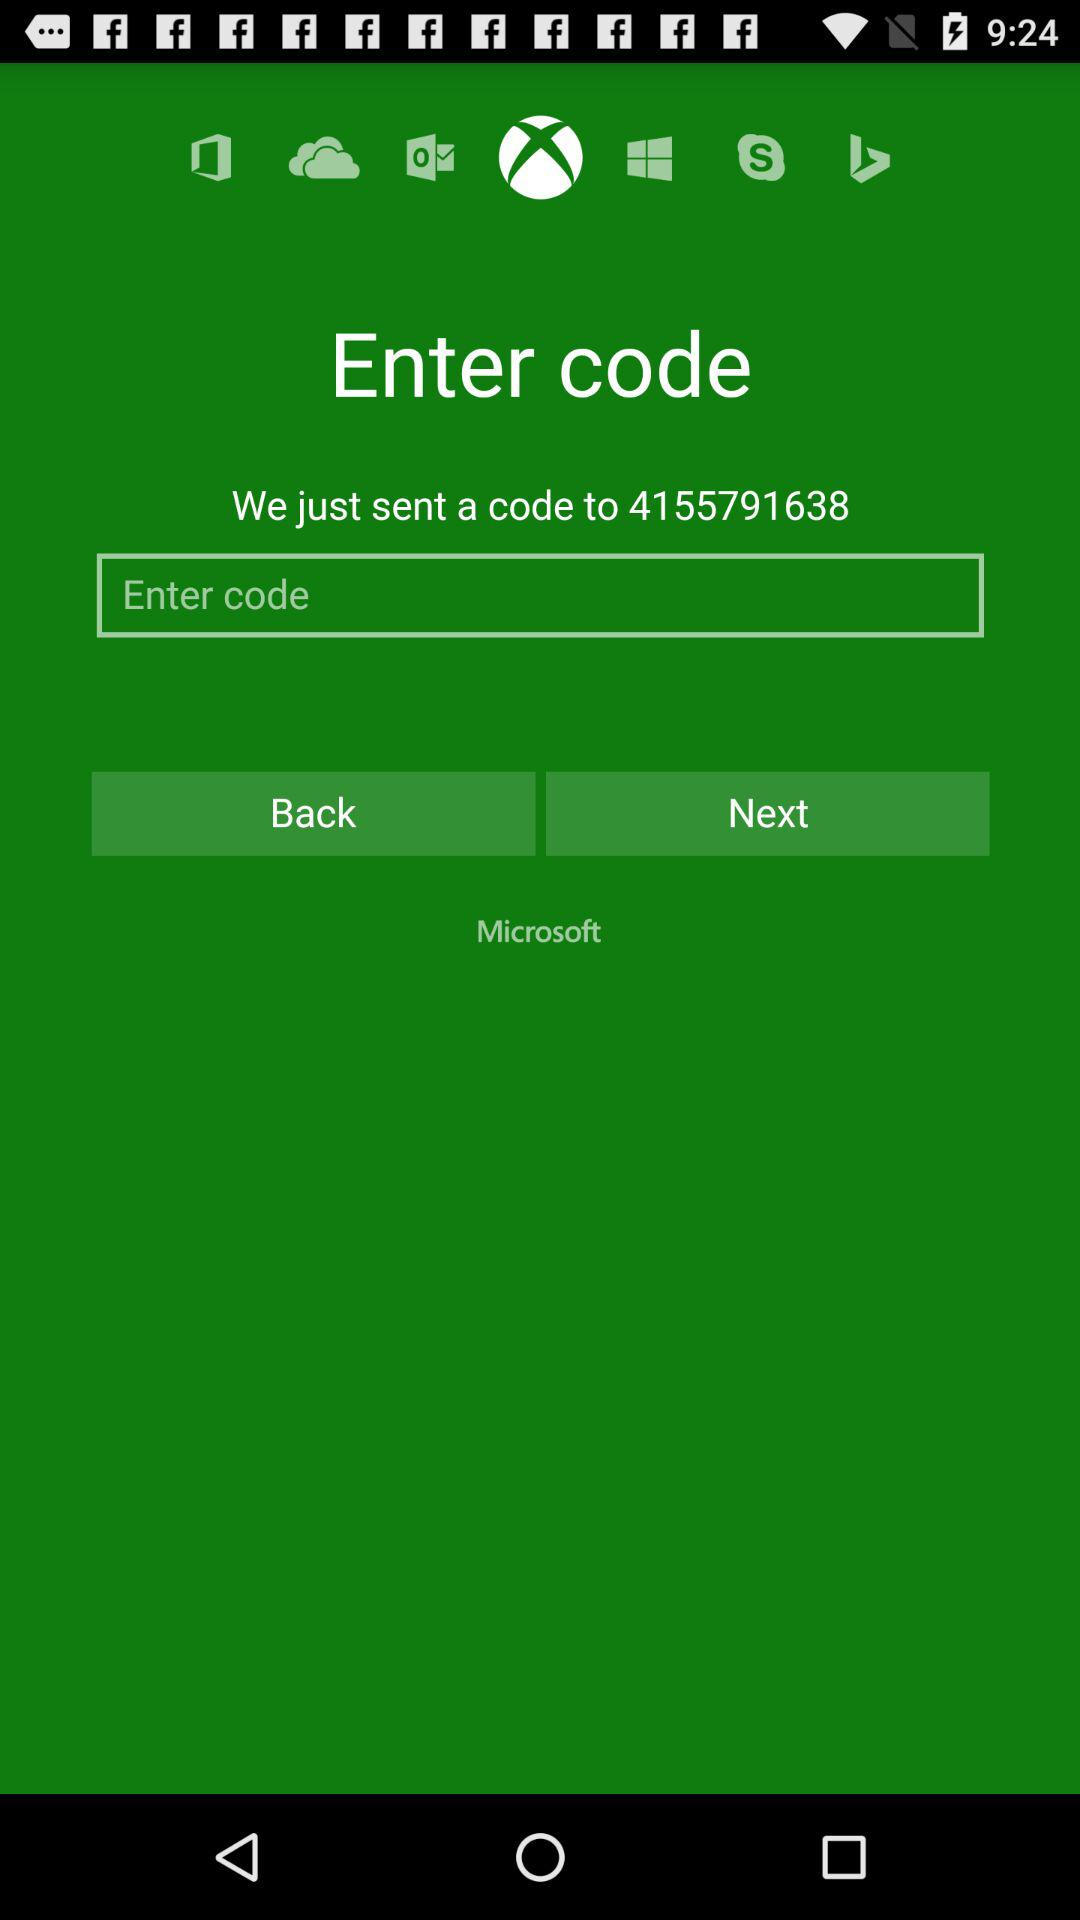Which application is selected? The selected application is "Xbox". 